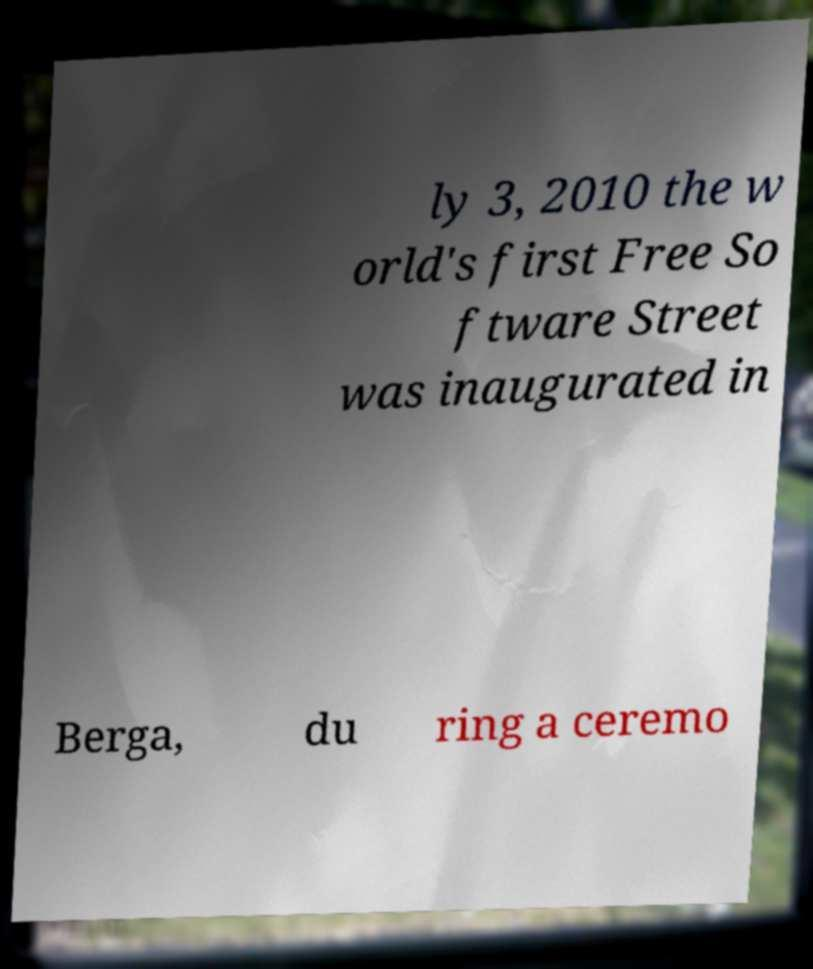Please identify and transcribe the text found in this image. ly 3, 2010 the w orld's first Free So ftware Street was inaugurated in Berga, du ring a ceremo 